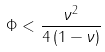<formula> <loc_0><loc_0><loc_500><loc_500>\Phi < \frac { \nu ^ { 2 } } { 4 \left ( 1 - \nu \right ) }</formula> 